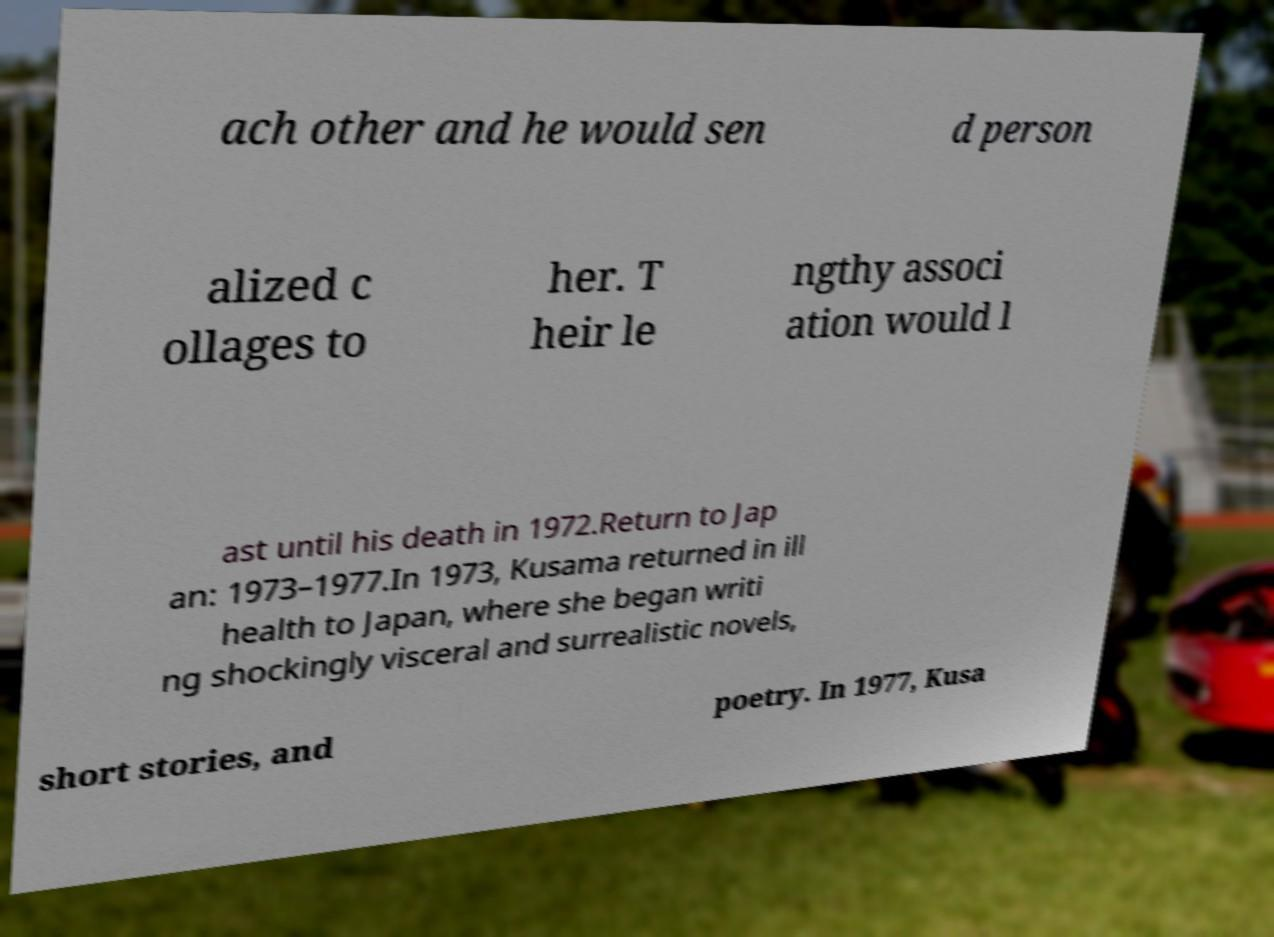I need the written content from this picture converted into text. Can you do that? ach other and he would sen d person alized c ollages to her. T heir le ngthy associ ation would l ast until his death in 1972.Return to Jap an: 1973–1977.In 1973, Kusama returned in ill health to Japan, where she began writi ng shockingly visceral and surrealistic novels, short stories, and poetry. In 1977, Kusa 